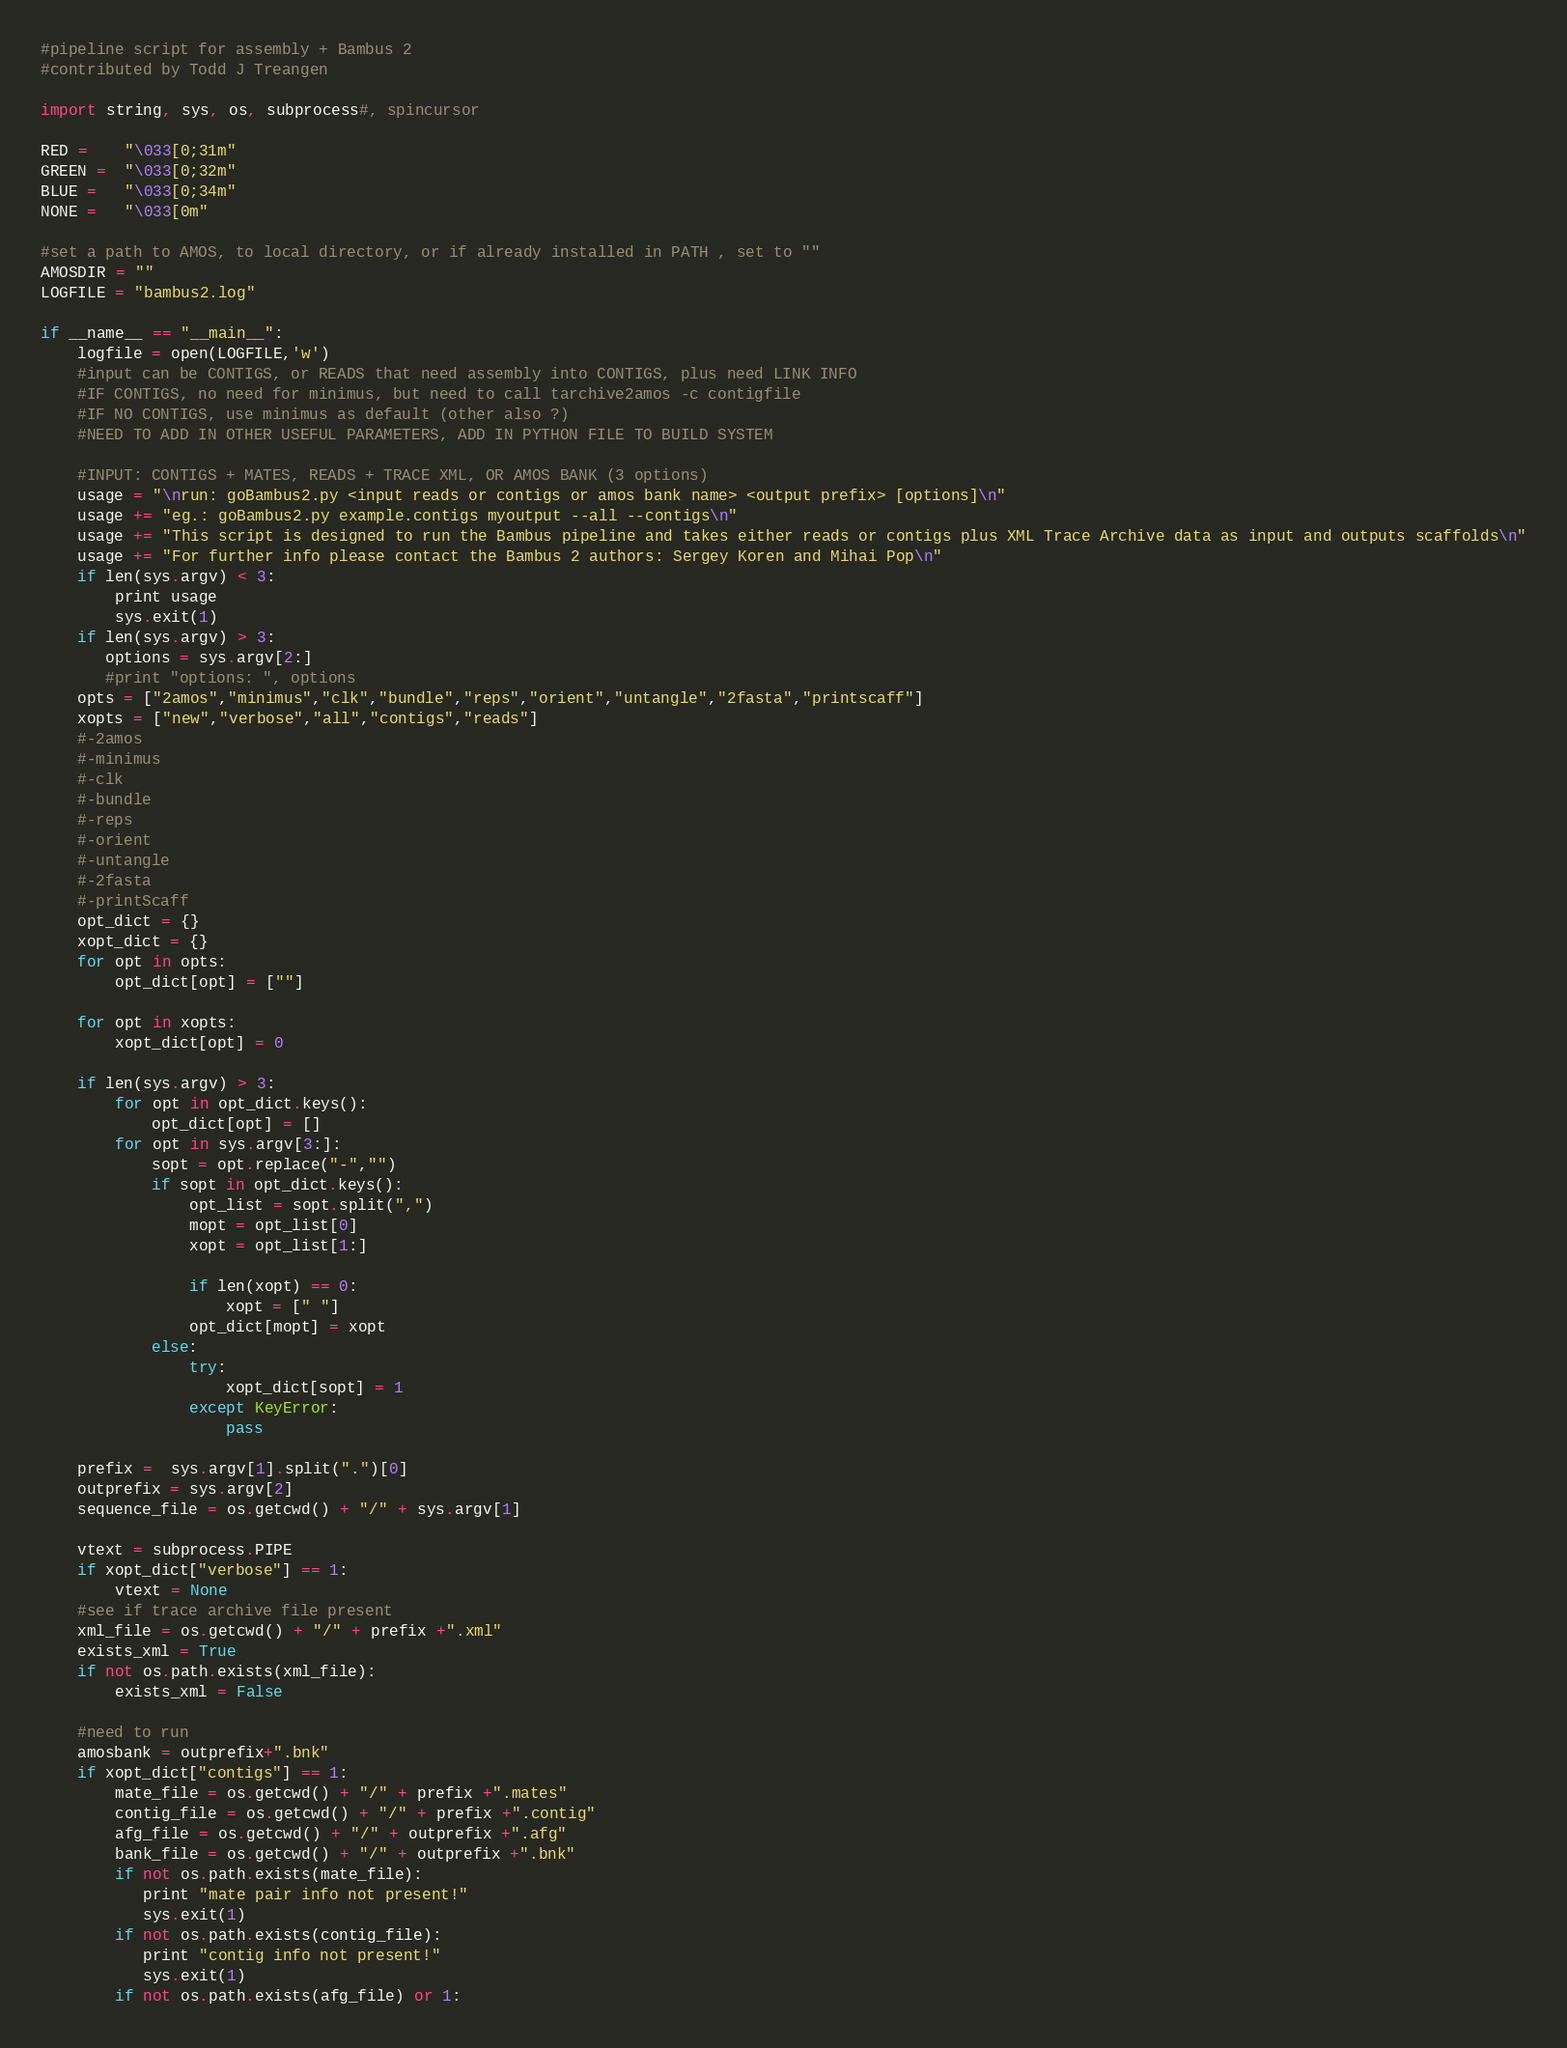<code> <loc_0><loc_0><loc_500><loc_500><_Python_>#pipeline script for assembly + Bambus 2
#contributed by Todd J Treangen

import string, sys, os, subprocess#, spincursor

RED =    "\033[0;31m"
GREEN =  "\033[0;32m"
BLUE =   "\033[0;34m"
NONE =   "\033[0m"

#set a path to AMOS, to local directory, or if already installed in PATH , set to ""
AMOSDIR = ""
LOGFILE = "bambus2.log"

if __name__ == "__main__":
    logfile = open(LOGFILE,'w')
    #input can be CONTIGS, or READS that need assembly into CONTIGS, plus need LINK INFO
    #IF CONTIGS, no need for minimus, but need to call tarchive2amos -c contigfile
    #IF NO CONTIGS, use minimus as default (other also ?)
    #NEED TO ADD IN OTHER USEFUL PARAMETERS, ADD IN PYTHON FILE TO BUILD SYSTEM

    #INPUT: CONTIGS + MATES, READS + TRACE XML, OR AMOS BANK (3 options)
    usage = "\nrun: goBambus2.py <input reads or contigs or amos bank name> <output prefix> [options]\n"
    usage += "eg.: goBambus2.py example.contigs myoutput --all --contigs\n"
    usage += "This script is designed to run the Bambus pipeline and takes either reads or contigs plus XML Trace Archive data as input and outputs scaffolds\n"
    usage += "For further info please contact the Bambus 2 authors: Sergey Koren and Mihai Pop\n"
    if len(sys.argv) < 3:
        print usage
        sys.exit(1)
    if len(sys.argv) > 3:
       options = sys.argv[2:]
       #print "options: ", options
    opts = ["2amos","minimus","clk","bundle","reps","orient","untangle","2fasta","printscaff"]
    xopts = ["new","verbose","all","contigs","reads"]
    #-2amos
    #-minimus
    #-clk
    #-bundle
    #-reps
    #-orient
    #-untangle
    #-2fasta
    #-printScaff
    opt_dict = {}
    xopt_dict = {}
    for opt in opts:
        opt_dict[opt] = [""]

    for opt in xopts:
        xopt_dict[opt] = 0
        
    if len(sys.argv) > 3:
        for opt in opt_dict.keys():
            opt_dict[opt] = []
        for opt in sys.argv[3:]:
            sopt = opt.replace("-","")
            if sopt in opt_dict.keys():
                opt_list = sopt.split(",")
                mopt = opt_list[0]
                xopt = opt_list[1:]
            
                if len(xopt) == 0:
                    xopt = [" "]
                opt_dict[mopt] = xopt
            else:
                try:
                    xopt_dict[sopt] = 1
                except KeyError:
                    pass
            
    prefix =  sys.argv[1].split(".")[0]
    outprefix = sys.argv[2]
    sequence_file = os.getcwd() + "/" + sys.argv[1]

    vtext = subprocess.PIPE
    if xopt_dict["verbose"] == 1:
        vtext = None
    #see if trace archive file present
    xml_file = os.getcwd() + "/" + prefix +".xml"
    exists_xml = True
    if not os.path.exists(xml_file):
        exists_xml = False

    #need to run
    amosbank = outprefix+".bnk"
    if xopt_dict["contigs"] == 1:
        mate_file = os.getcwd() + "/" + prefix +".mates"
        contig_file = os.getcwd() + "/" + prefix +".contig"
        afg_file = os.getcwd() + "/" + outprefix +".afg"
        bank_file = os.getcwd() + "/" + outprefix +".bnk"
        if not os.path.exists(mate_file):
           print "mate pair info not present!"
           sys.exit(1)
        if not os.path.exists(contig_file):
           print "contig info not present!"
           sys.exit(1)
        if not os.path.exists(afg_file) or 1:</code> 